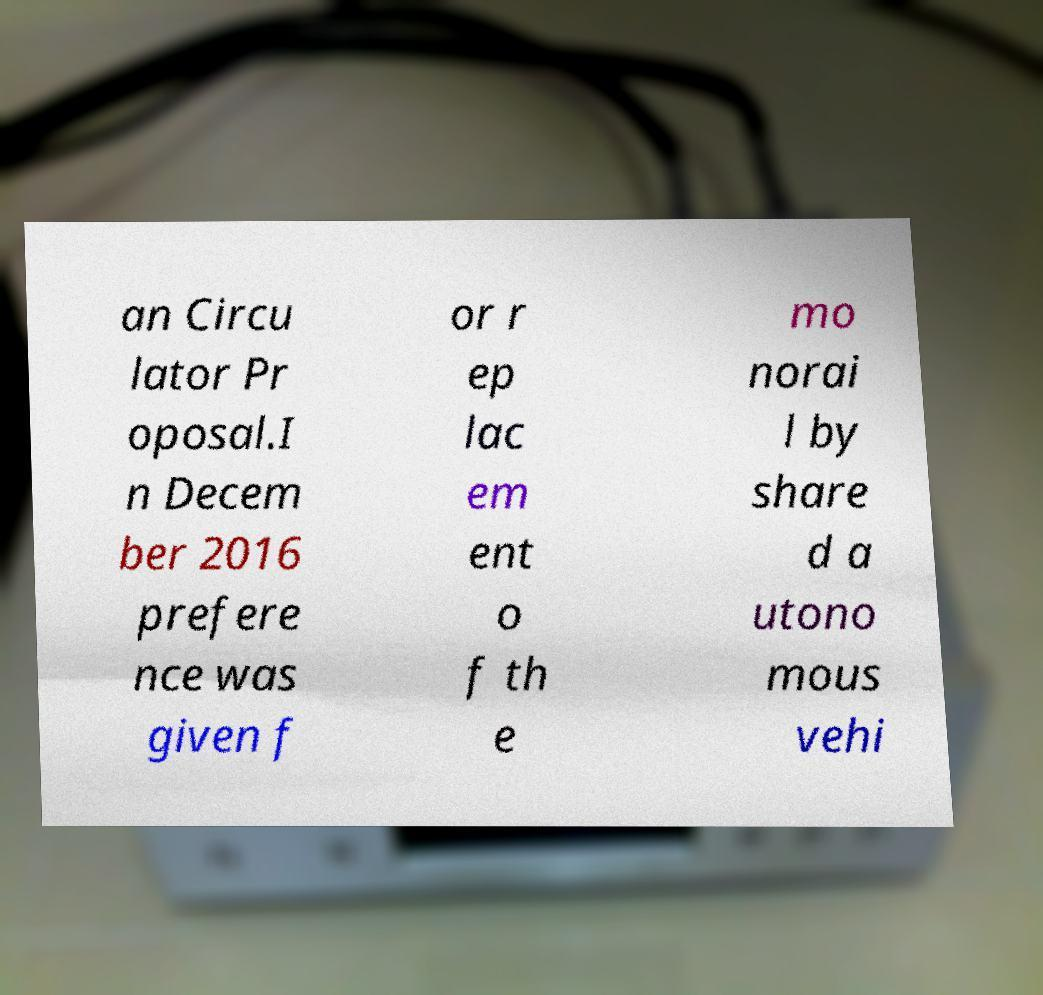Could you extract and type out the text from this image? an Circu lator Pr oposal.I n Decem ber 2016 prefere nce was given f or r ep lac em ent o f th e mo norai l by share d a utono mous vehi 